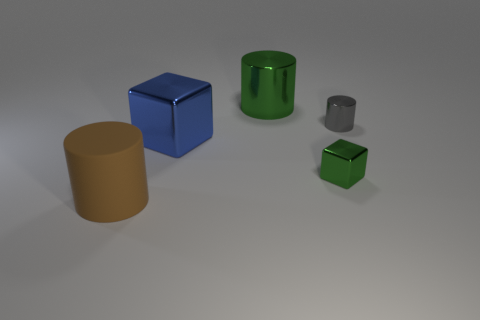Is there anything else that is the same material as the big brown object?
Your response must be concise. No. How many tiny blocks are on the right side of the block to the left of the large thing behind the large blue thing?
Offer a very short reply. 1. The gray object has what size?
Offer a terse response. Small. Is the color of the tiny cube the same as the large metallic cylinder?
Your response must be concise. Yes. There is a green object that is behind the big cube; how big is it?
Your answer should be very brief. Large. Do the block that is on the right side of the big green cylinder and the large cylinder to the right of the large brown rubber cylinder have the same color?
Make the answer very short. Yes. What number of other objects are there of the same shape as the big blue thing?
Your answer should be compact. 1. Are there an equal number of large green metallic cylinders that are right of the gray cylinder and metallic cubes in front of the large blue shiny block?
Ensure brevity in your answer.  No. Is the material of the big cylinder that is on the right side of the large brown thing the same as the cylinder that is left of the big green shiny cylinder?
Your response must be concise. No. How many other things are the same size as the brown rubber thing?
Make the answer very short. 2. 